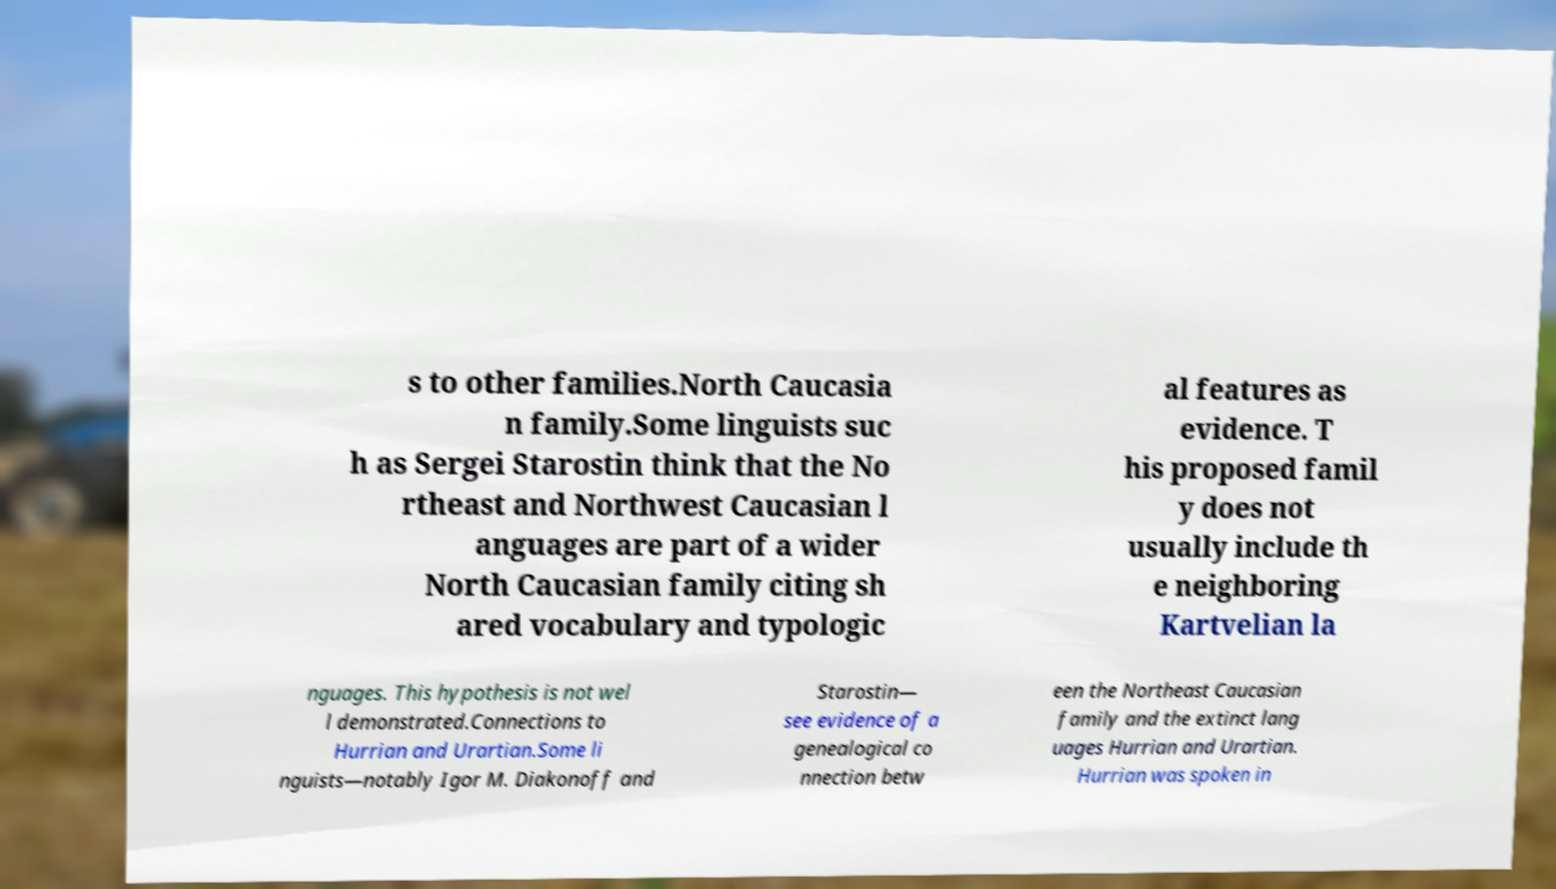What messages or text are displayed in this image? I need them in a readable, typed format. s to other families.North Caucasia n family.Some linguists suc h as Sergei Starostin think that the No rtheast and Northwest Caucasian l anguages are part of a wider North Caucasian family citing sh ared vocabulary and typologic al features as evidence. T his proposed famil y does not usually include th e neighboring Kartvelian la nguages. This hypothesis is not wel l demonstrated.Connections to Hurrian and Urartian.Some li nguists—notably Igor M. Diakonoff and Starostin— see evidence of a genealogical co nnection betw een the Northeast Caucasian family and the extinct lang uages Hurrian and Urartian. Hurrian was spoken in 